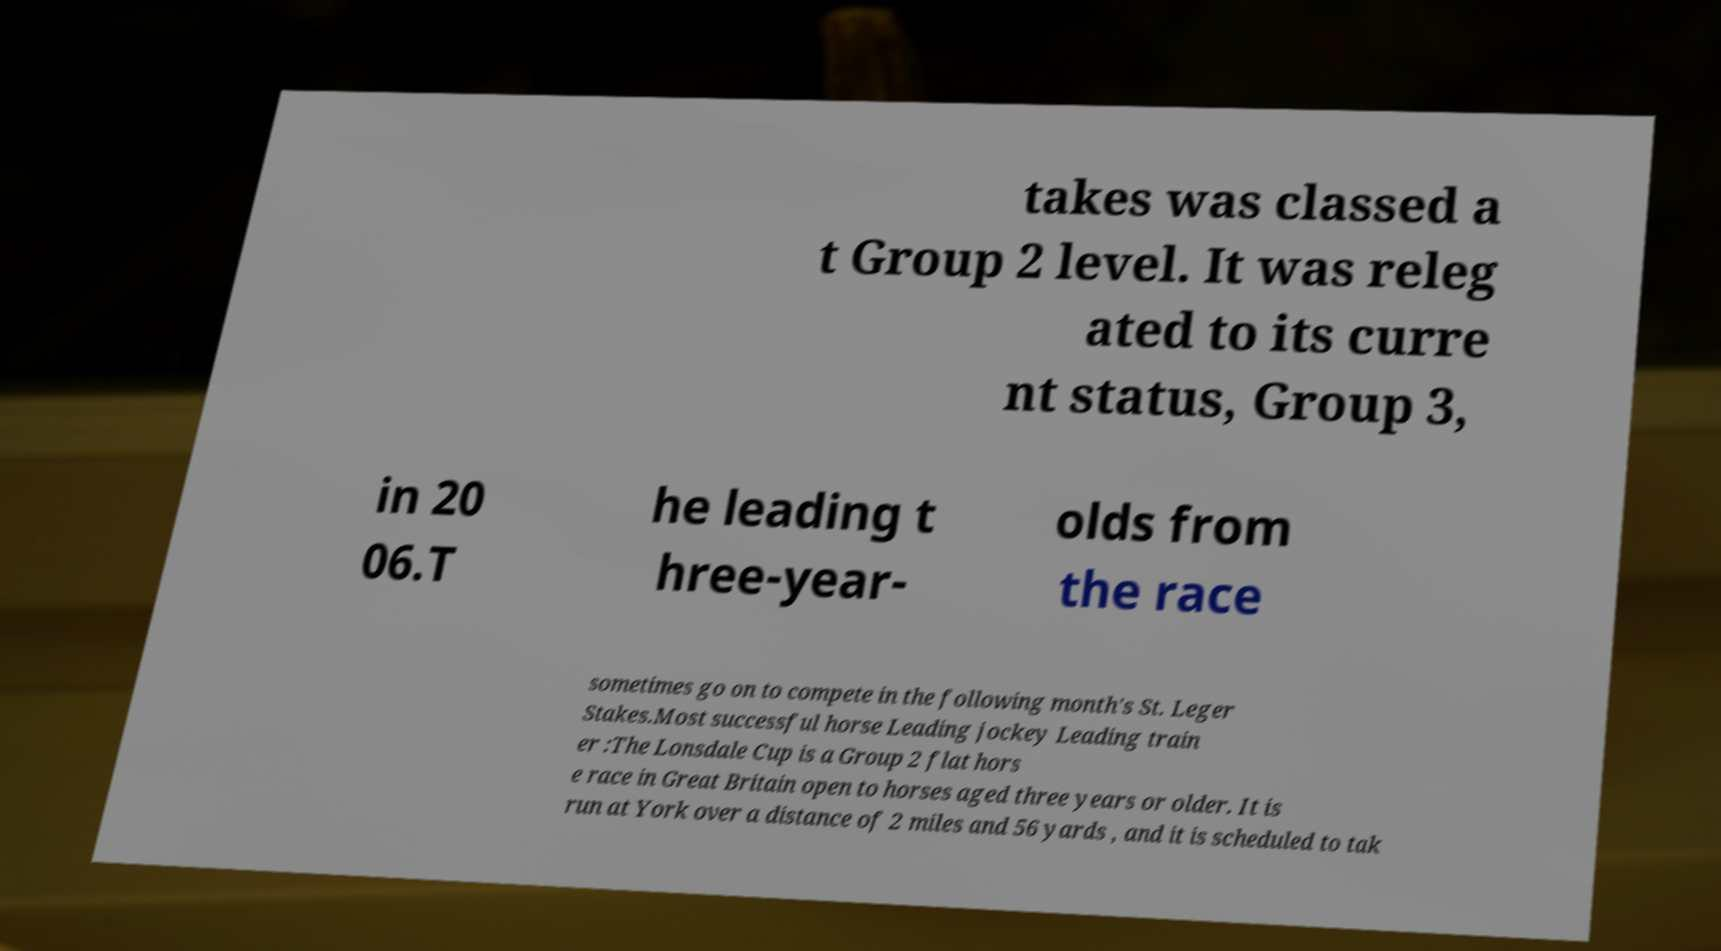Please identify and transcribe the text found in this image. takes was classed a t Group 2 level. It was releg ated to its curre nt status, Group 3, in 20 06.T he leading t hree-year- olds from the race sometimes go on to compete in the following month's St. Leger Stakes.Most successful horse Leading jockey Leading train er :The Lonsdale Cup is a Group 2 flat hors e race in Great Britain open to horses aged three years or older. It is run at York over a distance of 2 miles and 56 yards , and it is scheduled to tak 